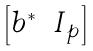Convert formula to latex. <formula><loc_0><loc_0><loc_500><loc_500>\begin{bmatrix} b ^ { * } & I _ { p } \end{bmatrix}</formula> 